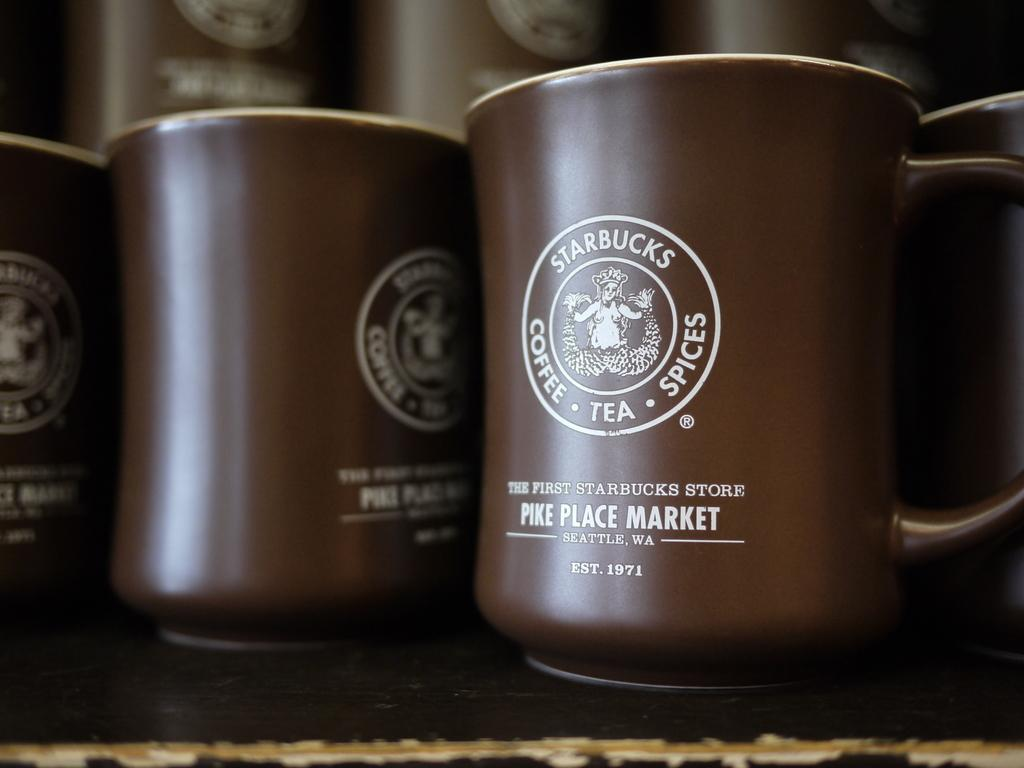<image>
Offer a succinct explanation of the picture presented. A brown Starbucks mug from Pike Place Market. 